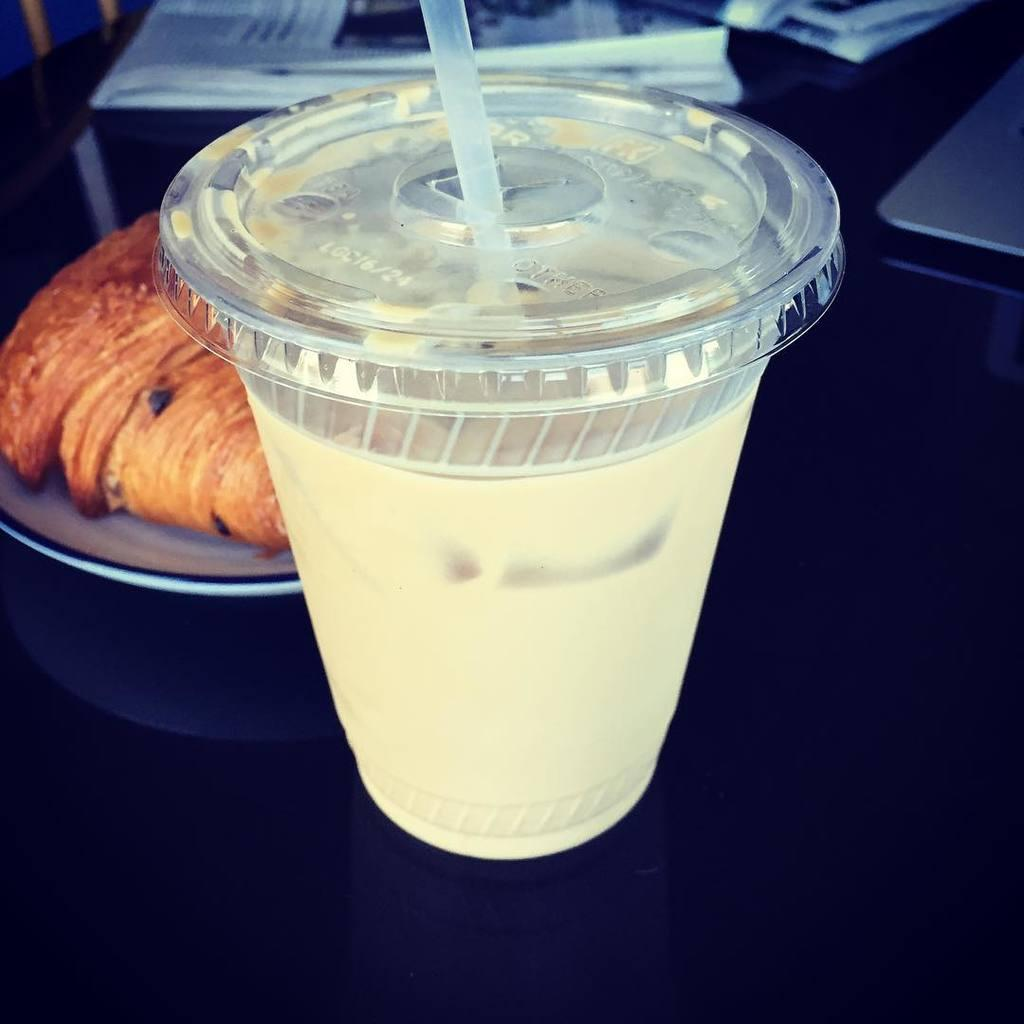What is on the table in the image? There is a cup and a plate with food in the image. Can you describe the plate and its contents? The plate is white, and the food on the plate is brown. What else can be seen on the table? There are papers on the table. What color is the table? The table is black. What type of teaching is happening in the image? There is no teaching happening in the image; it only shows a cup, a plate with food, papers, and a table. What discovery was made on the table in the image? There is no discovery mentioned or depicted in the image; it only shows a cup, a plate with food, papers, and a table. 